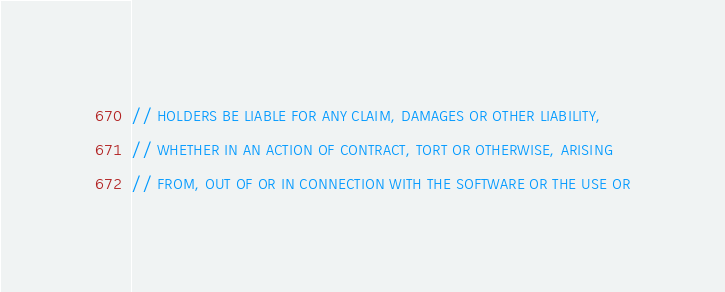<code> <loc_0><loc_0><loc_500><loc_500><_C++_>// HOLDERS BE LIABLE FOR ANY CLAIM, DAMAGES OR OTHER LIABILITY,
// WHETHER IN AN ACTION OF CONTRACT, TORT OR OTHERWISE, ARISING
// FROM, OUT OF OR IN CONNECTION WITH THE SOFTWARE OR THE USE OR</code> 